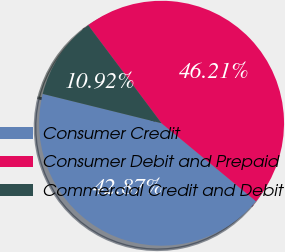<chart> <loc_0><loc_0><loc_500><loc_500><pie_chart><fcel>Consumer Credit<fcel>Consumer Debit and Prepaid<fcel>Commercial Credit and Debit<nl><fcel>42.87%<fcel>46.21%<fcel>10.92%<nl></chart> 